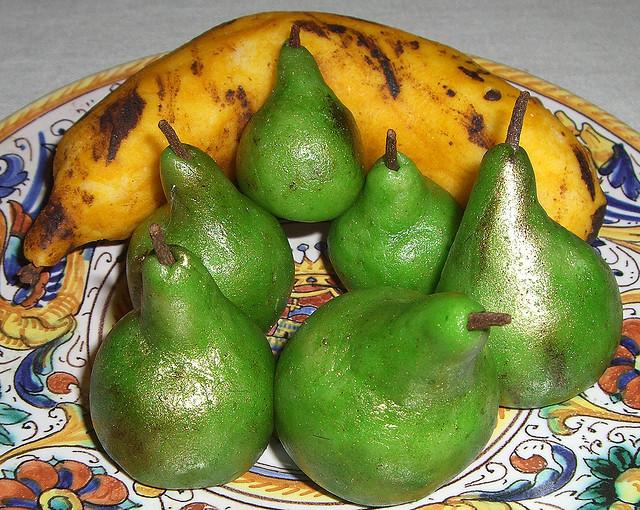How many pears are in front of the banana?
Write a very short answer. 6. Are the pears all the same size?
Quick response, please. No. Is the plate just one solid color?
Quick response, please. No. 